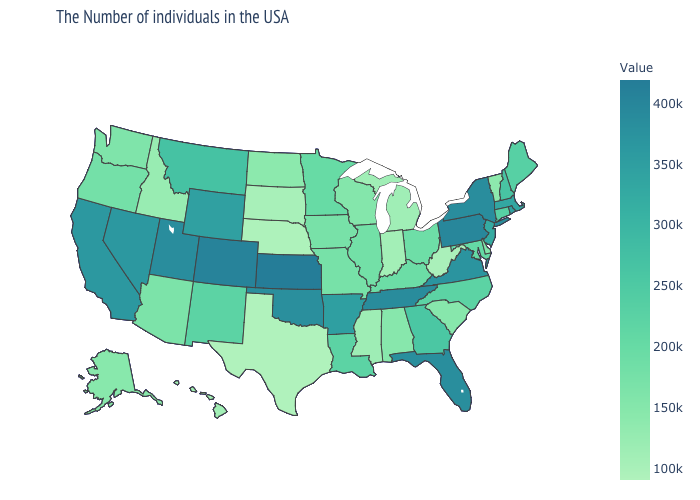Which states have the lowest value in the West?
Write a very short answer. Hawaii. Which states have the lowest value in the USA?
Answer briefly. Texas. Does Maine have the highest value in the USA?
Write a very short answer. No. Which states have the lowest value in the South?
Quick response, please. Texas. Does Rhode Island have the lowest value in the USA?
Short answer required. No. Does Louisiana have the highest value in the South?
Short answer required. No. 